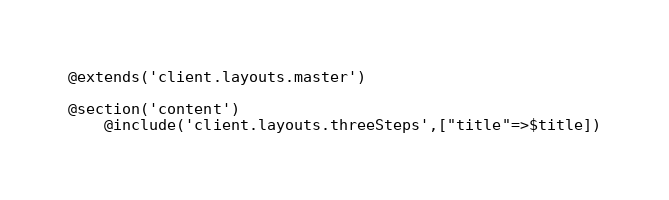<code> <loc_0><loc_0><loc_500><loc_500><_PHP_>@extends('client.layouts.master')

@section('content')
    @include('client.layouts.threeSteps',["title"=>$title])</code> 